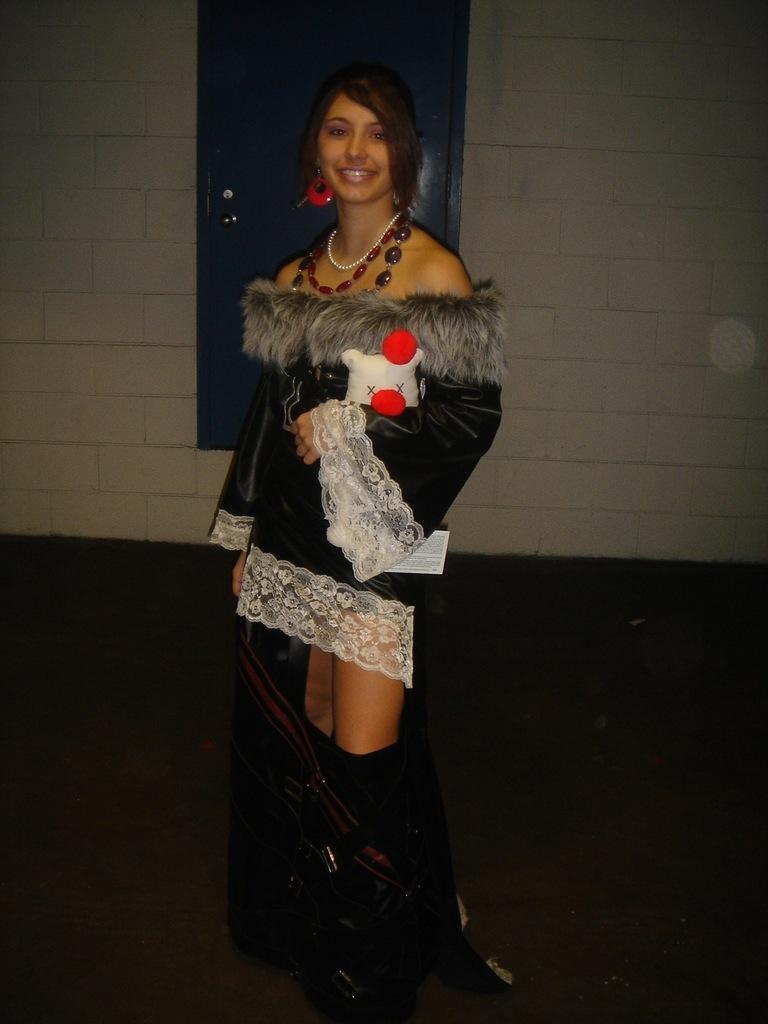How would you summarize this image in a sentence or two? In the image we can see there is a woman standing and she is wearing jacket. There is a door on the wall. 